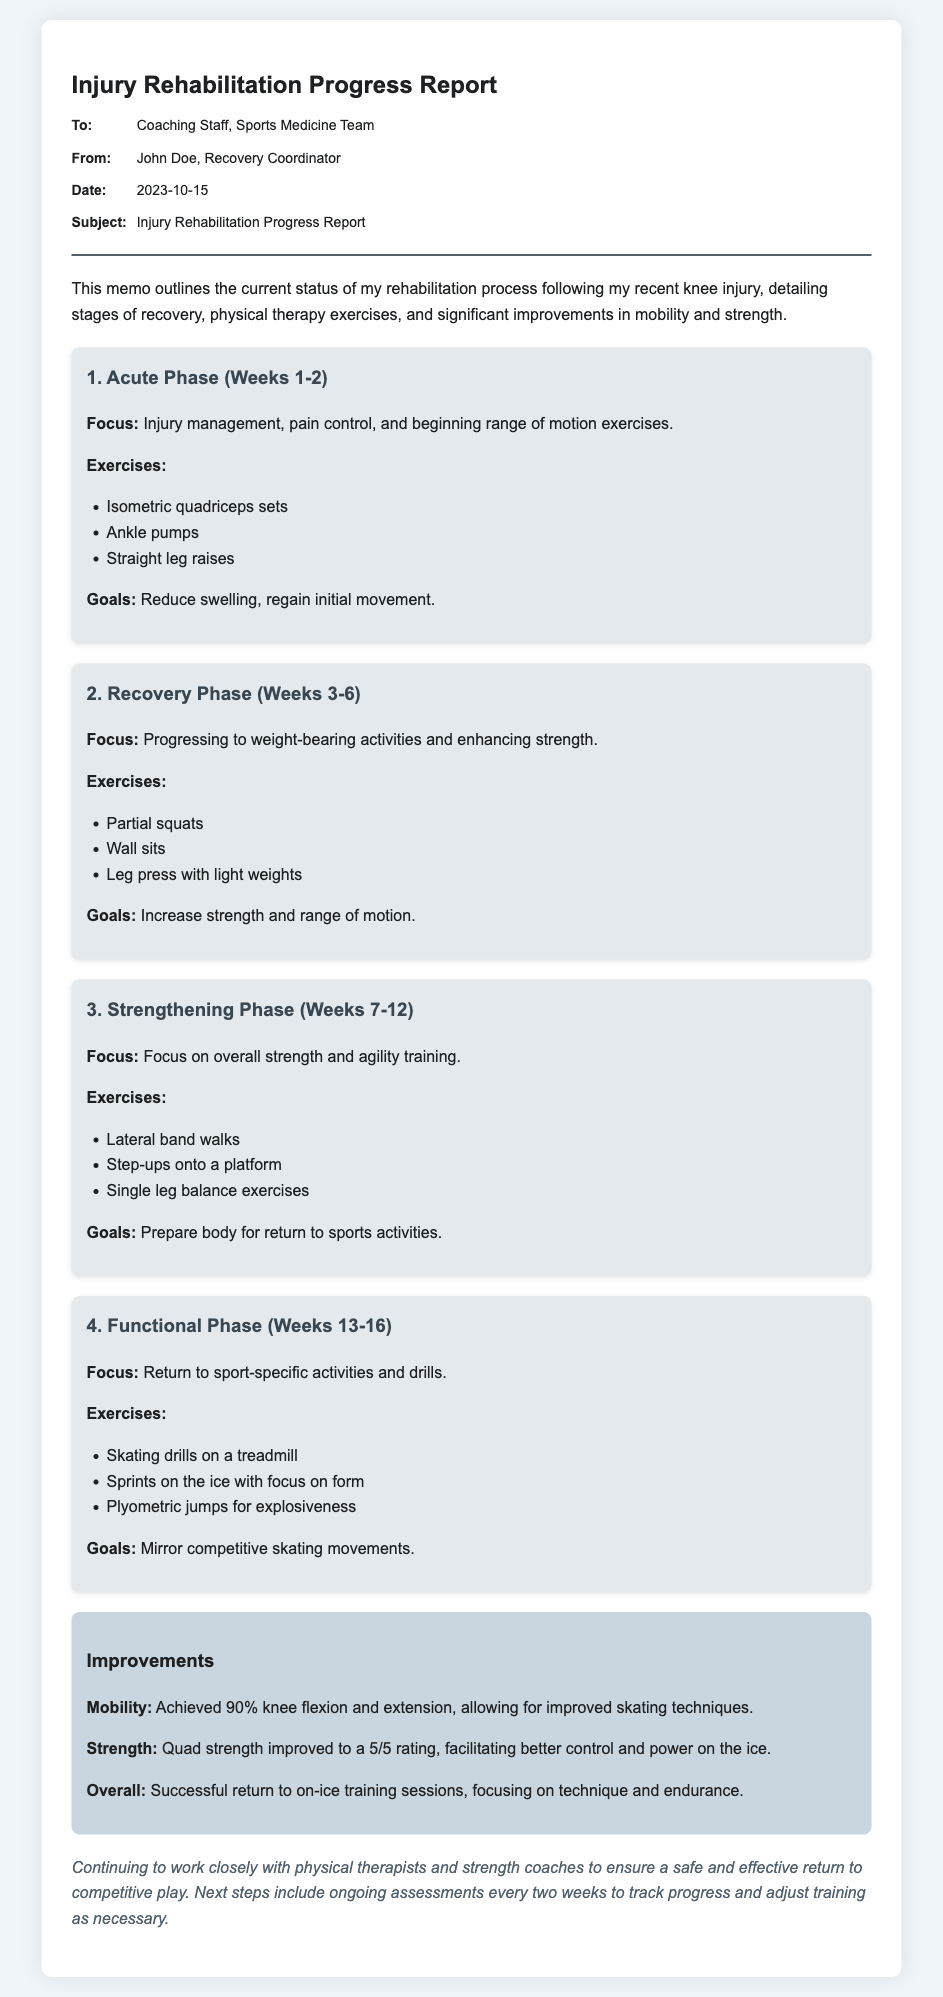What is the date of the report? The date of the report is found in the memo's header, which states "Date: 2023-10-15."
Answer: 2023-10-15 Who is the author of the report? The author is mentioned in the "From:" section of the memo as "John Doe, Recovery Coordinator."
Answer: John Doe What is the primary focus of the Acute Phase? The focus is specified in the bullet point under the first stage as "Injury management, pain control, and beginning range of motion exercises."
Answer: Injury management, pain control, and beginning range of motion exercises What is the goal during the Strengthening Phase? The goal can be found in the detailed description of this phase, which states "Prepare body for return to sports activities."
Answer: Prepare body for return to sports activities What percentage of knee flexion and extension has been achieved? The improvements section mentions "Achieved 90% knee flexion and extension."
Answer: 90% What type of exercises are included in the Functional Phase? The Functional Phase outlines "Skating drills on a treadmill, Sprints on the ice with focus on form, Plyometric jumps for explosiveness."
Answer: Skating drills on a treadmill, Sprints on the ice with focus on form, Plyometric jumps for explosiveness How often will assessments be conducted from now on? The conclusion specifies "ongoing assessments every two weeks."
Answer: every two weeks What is the overall rating of quad strength improvement? The improvements section notes the quad strength improved to "a 5/5 rating."
Answer: 5/5 rating 